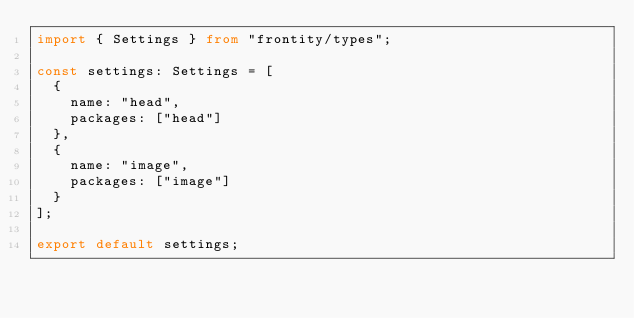Convert code to text. <code><loc_0><loc_0><loc_500><loc_500><_TypeScript_>import { Settings } from "frontity/types";

const settings: Settings = [
  {
    name: "head",
    packages: ["head"]
  },
  {
    name: "image",
    packages: ["image"]
  }
];

export default settings;
</code> 